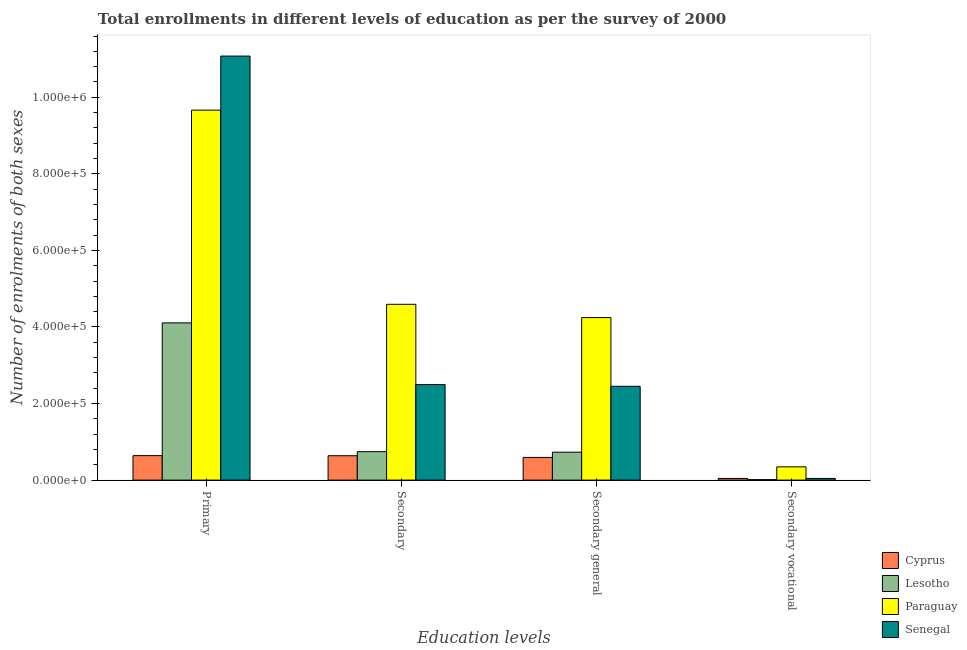How many different coloured bars are there?
Keep it short and to the point. 4. Are the number of bars on each tick of the X-axis equal?
Offer a very short reply. Yes. How many bars are there on the 4th tick from the right?
Offer a terse response. 4. What is the label of the 3rd group of bars from the left?
Your response must be concise. Secondary general. What is the number of enrolments in secondary education in Lesotho?
Provide a succinct answer. 7.43e+04. Across all countries, what is the maximum number of enrolments in primary education?
Offer a very short reply. 1.11e+06. Across all countries, what is the minimum number of enrolments in secondary education?
Provide a short and direct response. 6.37e+04. In which country was the number of enrolments in secondary general education maximum?
Ensure brevity in your answer.  Paraguay. In which country was the number of enrolments in secondary general education minimum?
Make the answer very short. Cyprus. What is the total number of enrolments in secondary general education in the graph?
Your answer should be very brief. 8.02e+05. What is the difference between the number of enrolments in secondary education in Cyprus and that in Paraguay?
Make the answer very short. -3.96e+05. What is the difference between the number of enrolments in secondary general education in Lesotho and the number of enrolments in secondary vocational education in Paraguay?
Provide a short and direct response. 3.84e+04. What is the average number of enrolments in secondary general education per country?
Your answer should be compact. 2.01e+05. What is the difference between the number of enrolments in secondary vocational education and number of enrolments in secondary general education in Lesotho?
Ensure brevity in your answer.  -7.17e+04. What is the ratio of the number of enrolments in secondary education in Senegal to that in Paraguay?
Give a very brief answer. 0.54. What is the difference between the highest and the second highest number of enrolments in secondary vocational education?
Keep it short and to the point. 3.02e+04. What is the difference between the highest and the lowest number of enrolments in secondary vocational education?
Keep it short and to the point. 3.33e+04. Is the sum of the number of enrolments in secondary general education in Paraguay and Cyprus greater than the maximum number of enrolments in secondary vocational education across all countries?
Ensure brevity in your answer.  Yes. What does the 4th bar from the left in Secondary general represents?
Your response must be concise. Senegal. What does the 4th bar from the right in Secondary general represents?
Keep it short and to the point. Cyprus. Are the values on the major ticks of Y-axis written in scientific E-notation?
Ensure brevity in your answer.  Yes. Does the graph contain any zero values?
Your answer should be very brief. No. Does the graph contain grids?
Your answer should be compact. No. Where does the legend appear in the graph?
Make the answer very short. Bottom right. How many legend labels are there?
Your response must be concise. 4. How are the legend labels stacked?
Give a very brief answer. Vertical. What is the title of the graph?
Provide a succinct answer. Total enrollments in different levels of education as per the survey of 2000. What is the label or title of the X-axis?
Your answer should be very brief. Education levels. What is the label or title of the Y-axis?
Make the answer very short. Number of enrolments of both sexes. What is the Number of enrolments of both sexes of Cyprus in Primary?
Your answer should be compact. 6.40e+04. What is the Number of enrolments of both sexes in Lesotho in Primary?
Your answer should be compact. 4.11e+05. What is the Number of enrolments of both sexes in Paraguay in Primary?
Give a very brief answer. 9.66e+05. What is the Number of enrolments of both sexes in Senegal in Primary?
Your answer should be compact. 1.11e+06. What is the Number of enrolments of both sexes in Cyprus in Secondary?
Offer a very short reply. 6.37e+04. What is the Number of enrolments of both sexes of Lesotho in Secondary?
Provide a succinct answer. 7.43e+04. What is the Number of enrolments of both sexes of Paraguay in Secondary?
Give a very brief answer. 4.59e+05. What is the Number of enrolments of both sexes in Senegal in Secondary?
Make the answer very short. 2.50e+05. What is the Number of enrolments of both sexes of Cyprus in Secondary general?
Ensure brevity in your answer.  5.93e+04. What is the Number of enrolments of both sexes of Lesotho in Secondary general?
Ensure brevity in your answer.  7.30e+04. What is the Number of enrolments of both sexes of Paraguay in Secondary general?
Provide a succinct answer. 4.25e+05. What is the Number of enrolments of both sexes in Senegal in Secondary general?
Your answer should be very brief. 2.45e+05. What is the Number of enrolments of both sexes of Cyprus in Secondary vocational?
Offer a very short reply. 4392. What is the Number of enrolments of both sexes of Lesotho in Secondary vocational?
Ensure brevity in your answer.  1321. What is the Number of enrolments of both sexes of Paraguay in Secondary vocational?
Your answer should be compact. 3.46e+04. What is the Number of enrolments of both sexes of Senegal in Secondary vocational?
Your answer should be compact. 4425. Across all Education levels, what is the maximum Number of enrolments of both sexes of Cyprus?
Your answer should be very brief. 6.40e+04. Across all Education levels, what is the maximum Number of enrolments of both sexes in Lesotho?
Your response must be concise. 4.11e+05. Across all Education levels, what is the maximum Number of enrolments of both sexes in Paraguay?
Ensure brevity in your answer.  9.66e+05. Across all Education levels, what is the maximum Number of enrolments of both sexes in Senegal?
Provide a short and direct response. 1.11e+06. Across all Education levels, what is the minimum Number of enrolments of both sexes of Cyprus?
Your answer should be very brief. 4392. Across all Education levels, what is the minimum Number of enrolments of both sexes of Lesotho?
Offer a terse response. 1321. Across all Education levels, what is the minimum Number of enrolments of both sexes in Paraguay?
Provide a succinct answer. 3.46e+04. Across all Education levels, what is the minimum Number of enrolments of both sexes of Senegal?
Ensure brevity in your answer.  4425. What is the total Number of enrolments of both sexes of Cyprus in the graph?
Keep it short and to the point. 1.91e+05. What is the total Number of enrolments of both sexes of Lesotho in the graph?
Provide a short and direct response. 5.59e+05. What is the total Number of enrolments of both sexes of Paraguay in the graph?
Make the answer very short. 1.88e+06. What is the total Number of enrolments of both sexes of Senegal in the graph?
Your response must be concise. 1.61e+06. What is the difference between the Number of enrolments of both sexes in Cyprus in Primary and that in Secondary?
Ensure brevity in your answer.  275. What is the difference between the Number of enrolments of both sexes in Lesotho in Primary and that in Secondary?
Offer a terse response. 3.36e+05. What is the difference between the Number of enrolments of both sexes in Paraguay in Primary and that in Secondary?
Make the answer very short. 5.07e+05. What is the difference between the Number of enrolments of both sexes in Senegal in Primary and that in Secondary?
Offer a very short reply. 8.58e+05. What is the difference between the Number of enrolments of both sexes in Cyprus in Primary and that in Secondary general?
Your response must be concise. 4667. What is the difference between the Number of enrolments of both sexes of Lesotho in Primary and that in Secondary general?
Give a very brief answer. 3.38e+05. What is the difference between the Number of enrolments of both sexes in Paraguay in Primary and that in Secondary general?
Provide a succinct answer. 5.42e+05. What is the difference between the Number of enrolments of both sexes in Senegal in Primary and that in Secondary general?
Provide a short and direct response. 8.63e+05. What is the difference between the Number of enrolments of both sexes in Cyprus in Primary and that in Secondary vocational?
Your response must be concise. 5.96e+04. What is the difference between the Number of enrolments of both sexes in Lesotho in Primary and that in Secondary vocational?
Ensure brevity in your answer.  4.09e+05. What is the difference between the Number of enrolments of both sexes in Paraguay in Primary and that in Secondary vocational?
Provide a succinct answer. 9.32e+05. What is the difference between the Number of enrolments of both sexes in Senegal in Primary and that in Secondary vocational?
Offer a very short reply. 1.10e+06. What is the difference between the Number of enrolments of both sexes in Cyprus in Secondary and that in Secondary general?
Ensure brevity in your answer.  4392. What is the difference between the Number of enrolments of both sexes in Lesotho in Secondary and that in Secondary general?
Keep it short and to the point. 1321. What is the difference between the Number of enrolments of both sexes of Paraguay in Secondary and that in Secondary general?
Ensure brevity in your answer.  3.46e+04. What is the difference between the Number of enrolments of both sexes of Senegal in Secondary and that in Secondary general?
Offer a very short reply. 4425. What is the difference between the Number of enrolments of both sexes in Cyprus in Secondary and that in Secondary vocational?
Offer a terse response. 5.93e+04. What is the difference between the Number of enrolments of both sexes of Lesotho in Secondary and that in Secondary vocational?
Your answer should be compact. 7.30e+04. What is the difference between the Number of enrolments of both sexes of Paraguay in Secondary and that in Secondary vocational?
Offer a very short reply. 4.25e+05. What is the difference between the Number of enrolments of both sexes of Senegal in Secondary and that in Secondary vocational?
Your response must be concise. 2.45e+05. What is the difference between the Number of enrolments of both sexes in Cyprus in Secondary general and that in Secondary vocational?
Provide a succinct answer. 5.49e+04. What is the difference between the Number of enrolments of both sexes of Lesotho in Secondary general and that in Secondary vocational?
Your answer should be compact. 7.17e+04. What is the difference between the Number of enrolments of both sexes in Paraguay in Secondary general and that in Secondary vocational?
Keep it short and to the point. 3.90e+05. What is the difference between the Number of enrolments of both sexes of Senegal in Secondary general and that in Secondary vocational?
Ensure brevity in your answer.  2.41e+05. What is the difference between the Number of enrolments of both sexes of Cyprus in Primary and the Number of enrolments of both sexes of Lesotho in Secondary?
Offer a terse response. -1.04e+04. What is the difference between the Number of enrolments of both sexes in Cyprus in Primary and the Number of enrolments of both sexes in Paraguay in Secondary?
Your response must be concise. -3.95e+05. What is the difference between the Number of enrolments of both sexes in Cyprus in Primary and the Number of enrolments of both sexes in Senegal in Secondary?
Your response must be concise. -1.86e+05. What is the difference between the Number of enrolments of both sexes in Lesotho in Primary and the Number of enrolments of both sexes in Paraguay in Secondary?
Provide a succinct answer. -4.85e+04. What is the difference between the Number of enrolments of both sexes of Lesotho in Primary and the Number of enrolments of both sexes of Senegal in Secondary?
Offer a terse response. 1.61e+05. What is the difference between the Number of enrolments of both sexes in Paraguay in Primary and the Number of enrolments of both sexes in Senegal in Secondary?
Provide a succinct answer. 7.17e+05. What is the difference between the Number of enrolments of both sexes in Cyprus in Primary and the Number of enrolments of both sexes in Lesotho in Secondary general?
Give a very brief answer. -9040. What is the difference between the Number of enrolments of both sexes of Cyprus in Primary and the Number of enrolments of both sexes of Paraguay in Secondary general?
Ensure brevity in your answer.  -3.61e+05. What is the difference between the Number of enrolments of both sexes in Cyprus in Primary and the Number of enrolments of both sexes in Senegal in Secondary general?
Your answer should be compact. -1.81e+05. What is the difference between the Number of enrolments of both sexes of Lesotho in Primary and the Number of enrolments of both sexes of Paraguay in Secondary general?
Give a very brief answer. -1.39e+04. What is the difference between the Number of enrolments of both sexes of Lesotho in Primary and the Number of enrolments of both sexes of Senegal in Secondary general?
Provide a short and direct response. 1.66e+05. What is the difference between the Number of enrolments of both sexes in Paraguay in Primary and the Number of enrolments of both sexes in Senegal in Secondary general?
Give a very brief answer. 7.21e+05. What is the difference between the Number of enrolments of both sexes in Cyprus in Primary and the Number of enrolments of both sexes in Lesotho in Secondary vocational?
Provide a succinct answer. 6.26e+04. What is the difference between the Number of enrolments of both sexes of Cyprus in Primary and the Number of enrolments of both sexes of Paraguay in Secondary vocational?
Keep it short and to the point. 2.93e+04. What is the difference between the Number of enrolments of both sexes of Cyprus in Primary and the Number of enrolments of both sexes of Senegal in Secondary vocational?
Make the answer very short. 5.95e+04. What is the difference between the Number of enrolments of both sexes in Lesotho in Primary and the Number of enrolments of both sexes in Paraguay in Secondary vocational?
Give a very brief answer. 3.76e+05. What is the difference between the Number of enrolments of both sexes of Lesotho in Primary and the Number of enrolments of both sexes of Senegal in Secondary vocational?
Provide a short and direct response. 4.06e+05. What is the difference between the Number of enrolments of both sexes of Paraguay in Primary and the Number of enrolments of both sexes of Senegal in Secondary vocational?
Give a very brief answer. 9.62e+05. What is the difference between the Number of enrolments of both sexes in Cyprus in Secondary and the Number of enrolments of both sexes in Lesotho in Secondary general?
Your response must be concise. -9315. What is the difference between the Number of enrolments of both sexes of Cyprus in Secondary and the Number of enrolments of both sexes of Paraguay in Secondary general?
Provide a short and direct response. -3.61e+05. What is the difference between the Number of enrolments of both sexes in Cyprus in Secondary and the Number of enrolments of both sexes in Senegal in Secondary general?
Offer a terse response. -1.81e+05. What is the difference between the Number of enrolments of both sexes in Lesotho in Secondary and the Number of enrolments of both sexes in Paraguay in Secondary general?
Provide a succinct answer. -3.50e+05. What is the difference between the Number of enrolments of both sexes in Lesotho in Secondary and the Number of enrolments of both sexes in Senegal in Secondary general?
Offer a terse response. -1.71e+05. What is the difference between the Number of enrolments of both sexes of Paraguay in Secondary and the Number of enrolments of both sexes of Senegal in Secondary general?
Your answer should be compact. 2.14e+05. What is the difference between the Number of enrolments of both sexes of Cyprus in Secondary and the Number of enrolments of both sexes of Lesotho in Secondary vocational?
Make the answer very short. 6.24e+04. What is the difference between the Number of enrolments of both sexes of Cyprus in Secondary and the Number of enrolments of both sexes of Paraguay in Secondary vocational?
Offer a terse response. 2.90e+04. What is the difference between the Number of enrolments of both sexes in Cyprus in Secondary and the Number of enrolments of both sexes in Senegal in Secondary vocational?
Make the answer very short. 5.93e+04. What is the difference between the Number of enrolments of both sexes of Lesotho in Secondary and the Number of enrolments of both sexes of Paraguay in Secondary vocational?
Make the answer very short. 3.97e+04. What is the difference between the Number of enrolments of both sexes in Lesotho in Secondary and the Number of enrolments of both sexes in Senegal in Secondary vocational?
Keep it short and to the point. 6.99e+04. What is the difference between the Number of enrolments of both sexes in Paraguay in Secondary and the Number of enrolments of both sexes in Senegal in Secondary vocational?
Offer a terse response. 4.55e+05. What is the difference between the Number of enrolments of both sexes in Cyprus in Secondary general and the Number of enrolments of both sexes in Lesotho in Secondary vocational?
Keep it short and to the point. 5.80e+04. What is the difference between the Number of enrolments of both sexes in Cyprus in Secondary general and the Number of enrolments of both sexes in Paraguay in Secondary vocational?
Make the answer very short. 2.46e+04. What is the difference between the Number of enrolments of both sexes of Cyprus in Secondary general and the Number of enrolments of both sexes of Senegal in Secondary vocational?
Offer a very short reply. 5.49e+04. What is the difference between the Number of enrolments of both sexes of Lesotho in Secondary general and the Number of enrolments of both sexes of Paraguay in Secondary vocational?
Offer a terse response. 3.84e+04. What is the difference between the Number of enrolments of both sexes of Lesotho in Secondary general and the Number of enrolments of both sexes of Senegal in Secondary vocational?
Offer a terse response. 6.86e+04. What is the difference between the Number of enrolments of both sexes of Paraguay in Secondary general and the Number of enrolments of both sexes of Senegal in Secondary vocational?
Your answer should be very brief. 4.20e+05. What is the average Number of enrolments of both sexes in Cyprus per Education levels?
Provide a succinct answer. 4.78e+04. What is the average Number of enrolments of both sexes of Lesotho per Education levels?
Your answer should be very brief. 1.40e+05. What is the average Number of enrolments of both sexes of Paraguay per Education levels?
Your answer should be compact. 4.71e+05. What is the average Number of enrolments of both sexes in Senegal per Education levels?
Your answer should be compact. 4.02e+05. What is the difference between the Number of enrolments of both sexes of Cyprus and Number of enrolments of both sexes of Lesotho in Primary?
Keep it short and to the point. -3.47e+05. What is the difference between the Number of enrolments of both sexes in Cyprus and Number of enrolments of both sexes in Paraguay in Primary?
Provide a succinct answer. -9.03e+05. What is the difference between the Number of enrolments of both sexes of Cyprus and Number of enrolments of both sexes of Senegal in Primary?
Your response must be concise. -1.04e+06. What is the difference between the Number of enrolments of both sexes of Lesotho and Number of enrolments of both sexes of Paraguay in Primary?
Offer a very short reply. -5.56e+05. What is the difference between the Number of enrolments of both sexes in Lesotho and Number of enrolments of both sexes in Senegal in Primary?
Your answer should be compact. -6.97e+05. What is the difference between the Number of enrolments of both sexes of Paraguay and Number of enrolments of both sexes of Senegal in Primary?
Offer a very short reply. -1.41e+05. What is the difference between the Number of enrolments of both sexes in Cyprus and Number of enrolments of both sexes in Lesotho in Secondary?
Keep it short and to the point. -1.06e+04. What is the difference between the Number of enrolments of both sexes of Cyprus and Number of enrolments of both sexes of Paraguay in Secondary?
Your response must be concise. -3.96e+05. What is the difference between the Number of enrolments of both sexes of Cyprus and Number of enrolments of both sexes of Senegal in Secondary?
Provide a short and direct response. -1.86e+05. What is the difference between the Number of enrolments of both sexes of Lesotho and Number of enrolments of both sexes of Paraguay in Secondary?
Keep it short and to the point. -3.85e+05. What is the difference between the Number of enrolments of both sexes of Lesotho and Number of enrolments of both sexes of Senegal in Secondary?
Offer a terse response. -1.75e+05. What is the difference between the Number of enrolments of both sexes of Paraguay and Number of enrolments of both sexes of Senegal in Secondary?
Your answer should be compact. 2.10e+05. What is the difference between the Number of enrolments of both sexes in Cyprus and Number of enrolments of both sexes in Lesotho in Secondary general?
Provide a short and direct response. -1.37e+04. What is the difference between the Number of enrolments of both sexes of Cyprus and Number of enrolments of both sexes of Paraguay in Secondary general?
Your answer should be very brief. -3.65e+05. What is the difference between the Number of enrolments of both sexes in Cyprus and Number of enrolments of both sexes in Senegal in Secondary general?
Keep it short and to the point. -1.86e+05. What is the difference between the Number of enrolments of both sexes in Lesotho and Number of enrolments of both sexes in Paraguay in Secondary general?
Offer a very short reply. -3.52e+05. What is the difference between the Number of enrolments of both sexes of Lesotho and Number of enrolments of both sexes of Senegal in Secondary general?
Make the answer very short. -1.72e+05. What is the difference between the Number of enrolments of both sexes in Paraguay and Number of enrolments of both sexes in Senegal in Secondary general?
Your response must be concise. 1.79e+05. What is the difference between the Number of enrolments of both sexes of Cyprus and Number of enrolments of both sexes of Lesotho in Secondary vocational?
Provide a short and direct response. 3071. What is the difference between the Number of enrolments of both sexes of Cyprus and Number of enrolments of both sexes of Paraguay in Secondary vocational?
Provide a succinct answer. -3.02e+04. What is the difference between the Number of enrolments of both sexes in Cyprus and Number of enrolments of both sexes in Senegal in Secondary vocational?
Keep it short and to the point. -33. What is the difference between the Number of enrolments of both sexes of Lesotho and Number of enrolments of both sexes of Paraguay in Secondary vocational?
Provide a short and direct response. -3.33e+04. What is the difference between the Number of enrolments of both sexes in Lesotho and Number of enrolments of both sexes in Senegal in Secondary vocational?
Your answer should be compact. -3104. What is the difference between the Number of enrolments of both sexes of Paraguay and Number of enrolments of both sexes of Senegal in Secondary vocational?
Ensure brevity in your answer.  3.02e+04. What is the ratio of the Number of enrolments of both sexes of Lesotho in Primary to that in Secondary?
Your response must be concise. 5.53. What is the ratio of the Number of enrolments of both sexes of Paraguay in Primary to that in Secondary?
Provide a short and direct response. 2.1. What is the ratio of the Number of enrolments of both sexes of Senegal in Primary to that in Secondary?
Your answer should be compact. 4.44. What is the ratio of the Number of enrolments of both sexes in Cyprus in Primary to that in Secondary general?
Provide a succinct answer. 1.08. What is the ratio of the Number of enrolments of both sexes of Lesotho in Primary to that in Secondary general?
Your answer should be compact. 5.63. What is the ratio of the Number of enrolments of both sexes in Paraguay in Primary to that in Secondary general?
Offer a very short reply. 2.28. What is the ratio of the Number of enrolments of both sexes of Senegal in Primary to that in Secondary general?
Your answer should be compact. 4.52. What is the ratio of the Number of enrolments of both sexes of Cyprus in Primary to that in Secondary vocational?
Offer a very short reply. 14.56. What is the ratio of the Number of enrolments of both sexes of Lesotho in Primary to that in Secondary vocational?
Give a very brief answer. 310.93. What is the ratio of the Number of enrolments of both sexes in Paraguay in Primary to that in Secondary vocational?
Offer a terse response. 27.9. What is the ratio of the Number of enrolments of both sexes in Senegal in Primary to that in Secondary vocational?
Offer a terse response. 250.33. What is the ratio of the Number of enrolments of both sexes of Cyprus in Secondary to that in Secondary general?
Your answer should be very brief. 1.07. What is the ratio of the Number of enrolments of both sexes in Lesotho in Secondary to that in Secondary general?
Offer a terse response. 1.02. What is the ratio of the Number of enrolments of both sexes in Paraguay in Secondary to that in Secondary general?
Offer a terse response. 1.08. What is the ratio of the Number of enrolments of both sexes in Senegal in Secondary to that in Secondary general?
Make the answer very short. 1.02. What is the ratio of the Number of enrolments of both sexes in Cyprus in Secondary to that in Secondary vocational?
Give a very brief answer. 14.5. What is the ratio of the Number of enrolments of both sexes of Lesotho in Secondary to that in Secondary vocational?
Offer a very short reply. 56.26. What is the ratio of the Number of enrolments of both sexes in Paraguay in Secondary to that in Secondary vocational?
Provide a succinct answer. 13.26. What is the ratio of the Number of enrolments of both sexes of Senegal in Secondary to that in Secondary vocational?
Offer a terse response. 56.39. What is the ratio of the Number of enrolments of both sexes of Cyprus in Secondary general to that in Secondary vocational?
Provide a succinct answer. 13.5. What is the ratio of the Number of enrolments of both sexes in Lesotho in Secondary general to that in Secondary vocational?
Ensure brevity in your answer.  55.26. What is the ratio of the Number of enrolments of both sexes of Paraguay in Secondary general to that in Secondary vocational?
Offer a terse response. 12.26. What is the ratio of the Number of enrolments of both sexes in Senegal in Secondary general to that in Secondary vocational?
Keep it short and to the point. 55.39. What is the difference between the highest and the second highest Number of enrolments of both sexes of Cyprus?
Offer a very short reply. 275. What is the difference between the highest and the second highest Number of enrolments of both sexes in Lesotho?
Ensure brevity in your answer.  3.36e+05. What is the difference between the highest and the second highest Number of enrolments of both sexes in Paraguay?
Your answer should be very brief. 5.07e+05. What is the difference between the highest and the second highest Number of enrolments of both sexes of Senegal?
Provide a succinct answer. 8.58e+05. What is the difference between the highest and the lowest Number of enrolments of both sexes of Cyprus?
Ensure brevity in your answer.  5.96e+04. What is the difference between the highest and the lowest Number of enrolments of both sexes of Lesotho?
Offer a terse response. 4.09e+05. What is the difference between the highest and the lowest Number of enrolments of both sexes in Paraguay?
Make the answer very short. 9.32e+05. What is the difference between the highest and the lowest Number of enrolments of both sexes of Senegal?
Offer a terse response. 1.10e+06. 